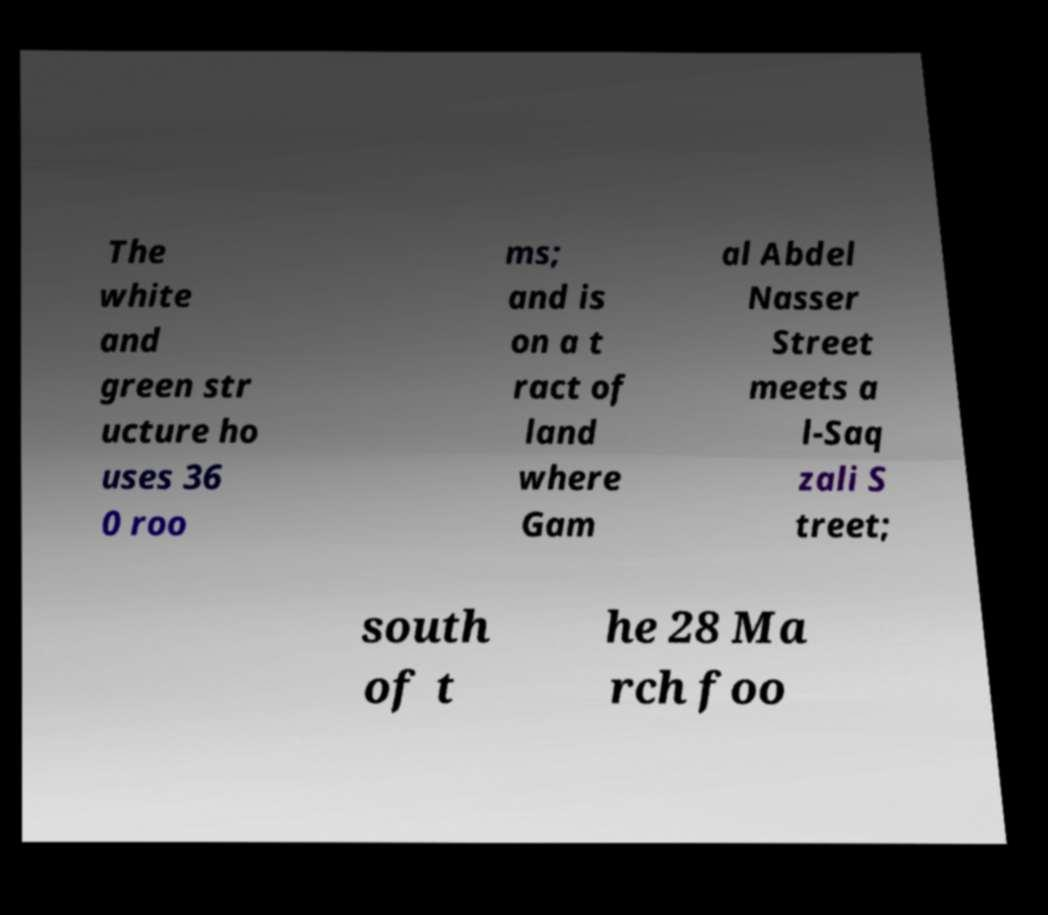Could you extract and type out the text from this image? The white and green str ucture ho uses 36 0 roo ms; and is on a t ract of land where Gam al Abdel Nasser Street meets a l-Saq zali S treet; south of t he 28 Ma rch foo 